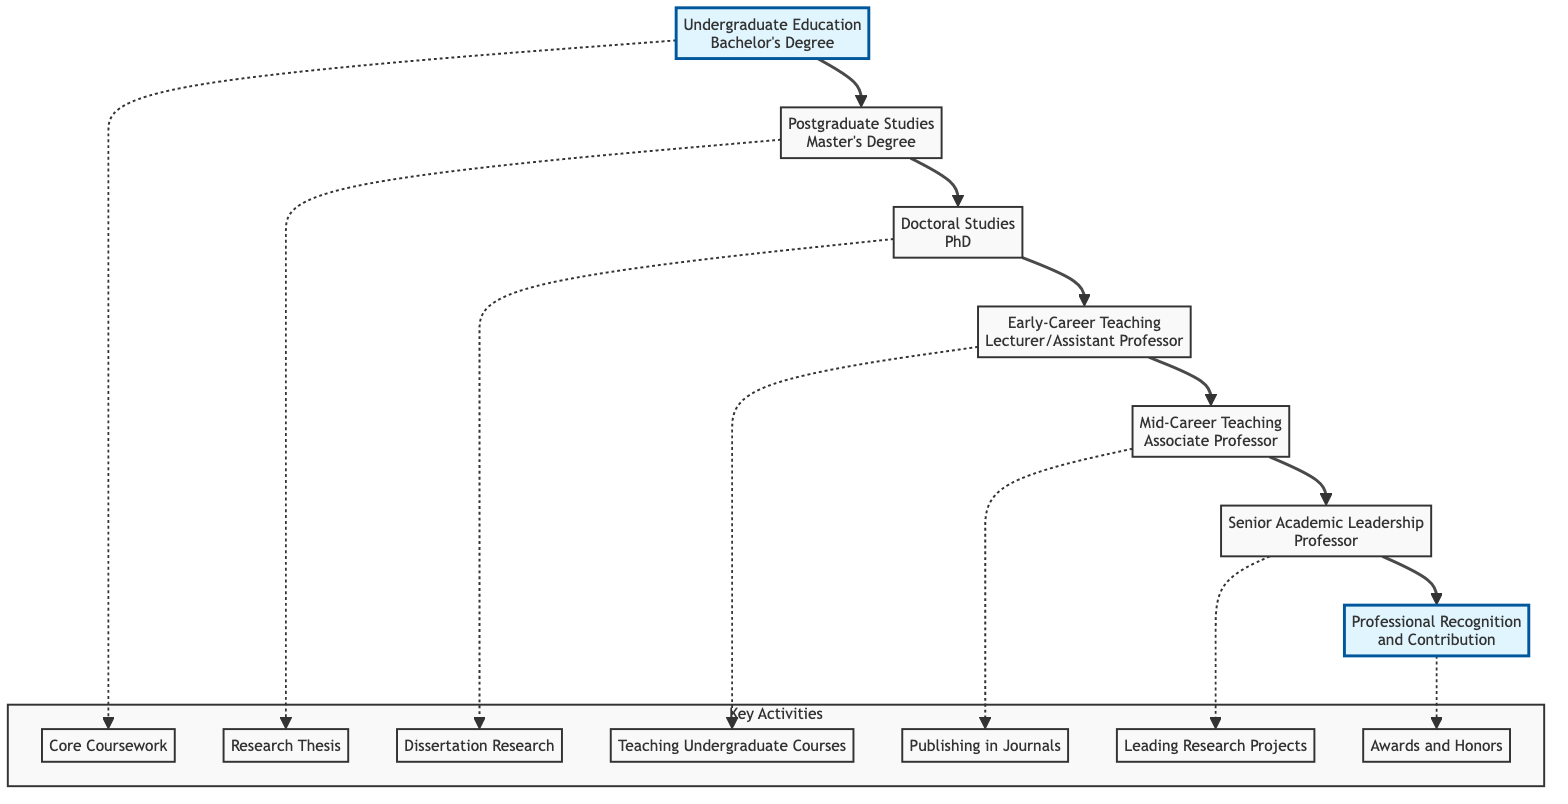What is the first step in the academic journey? The first step in the journey, according to the diagram, is "Undergraduate Education," which includes obtaining a Bachelor's Degree in Engineering Technology.
Answer: Undergraduate Education How many key activities are listed under "Doctoral Studies"? The diagram provides three key activities listed under "Doctoral Studies," which are "Dissertation Research," "Conference Presentations," and "Publications in Journals."
Answer: 3 Which position comes after "Early-Career Teaching Positions"? The position that follows "Early-Career Teaching Positions" in the flow is "Mid-Career Teaching and Research," which is denoted as Associate Professor.
Answer: Mid-Career Teaching and Research What is the highest academic rank mentioned in the diagram? The highest rank indicated in the diagram is "Senior Academic Leadership," defined as Professor, which is the last step before achieving professional recognition.
Answer: Professor How many institutions are associated with "Postgraduate Studies"? There are two institutions listed for "Postgraduate Studies": "University of Batna" and "University of Algiers," completing this step in the academic path.
Answer: 2 What is the relationship between "Mid-Career Teaching" and "Professional Recognition"? "Mid-Career Teaching" involves positions such as Associate Professor, which leads directly to "Professional Recognition and Contribution," indicating that maintaining an academic career can produce significant professional achievements.
Answer: Leads to What activity is emphasized at the "Senior Academic Leadership" level? The diagram highlights "Leading Research Projects" as a key activity at the "Senior Academic Leadership" level, denoting a focus on impactful academic contributions.
Answer: Leading Research Projects What is indicated as a crucial activity in "Postgraduate Studies"? The diagram labels "Research Thesis" as a crucial activity within "Postgraduate Studies," showcasing the importance of research in advancing academic qualifications.
Answer: Research Thesis What step follows the publication of journals in "Mid-Career Teaching"? The step that comes after publishing in journals, as per the diagram, is "Senior Academic Leadership," where individuals are expected to lead research efforts and mentor others.
Answer: Senior Academic Leadership 